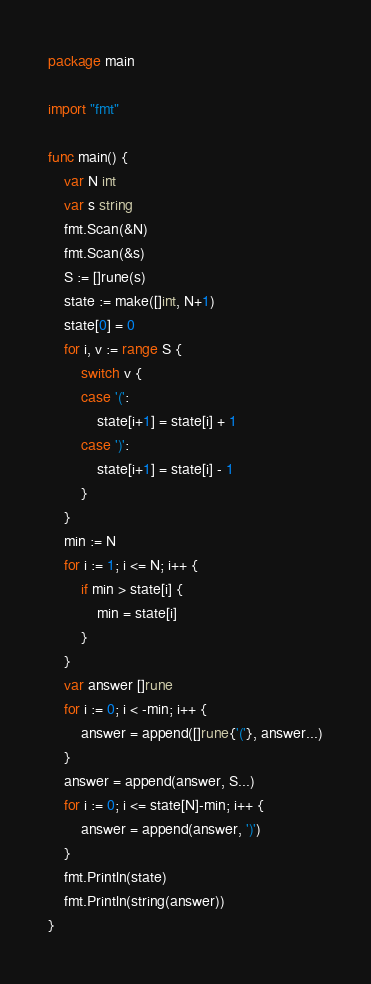<code> <loc_0><loc_0><loc_500><loc_500><_Go_>package main

import "fmt"

func main() {
	var N int
	var s string
	fmt.Scan(&N)
	fmt.Scan(&s)
	S := []rune(s)
	state := make([]int, N+1)
	state[0] = 0
	for i, v := range S {
		switch v {
		case '(':
			state[i+1] = state[i] + 1
		case ')':
			state[i+1] = state[i] - 1
		}
	}
	min := N
	for i := 1; i <= N; i++ {
		if min > state[i] {
			min = state[i]
		}
	}
	var answer []rune
	for i := 0; i < -min; i++ {
		answer = append([]rune{'('}, answer...)
	}
	answer = append(answer, S...)
	for i := 0; i <= state[N]-min; i++ {
		answer = append(answer, ')')
	}
	fmt.Println(state)
	fmt.Println(string(answer))
}
</code> 